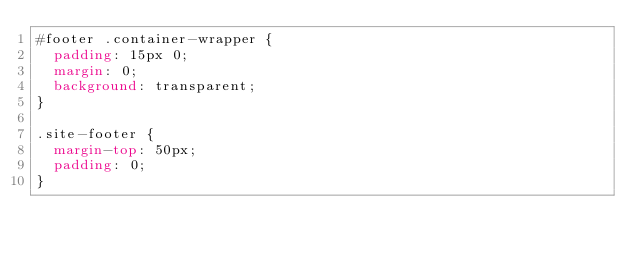<code> <loc_0><loc_0><loc_500><loc_500><_CSS_>#footer .container-wrapper {
  padding: 15px 0;
  margin: 0;
  background: transparent;
}

.site-footer {
  margin-top: 50px;
  padding: 0;
}
</code> 